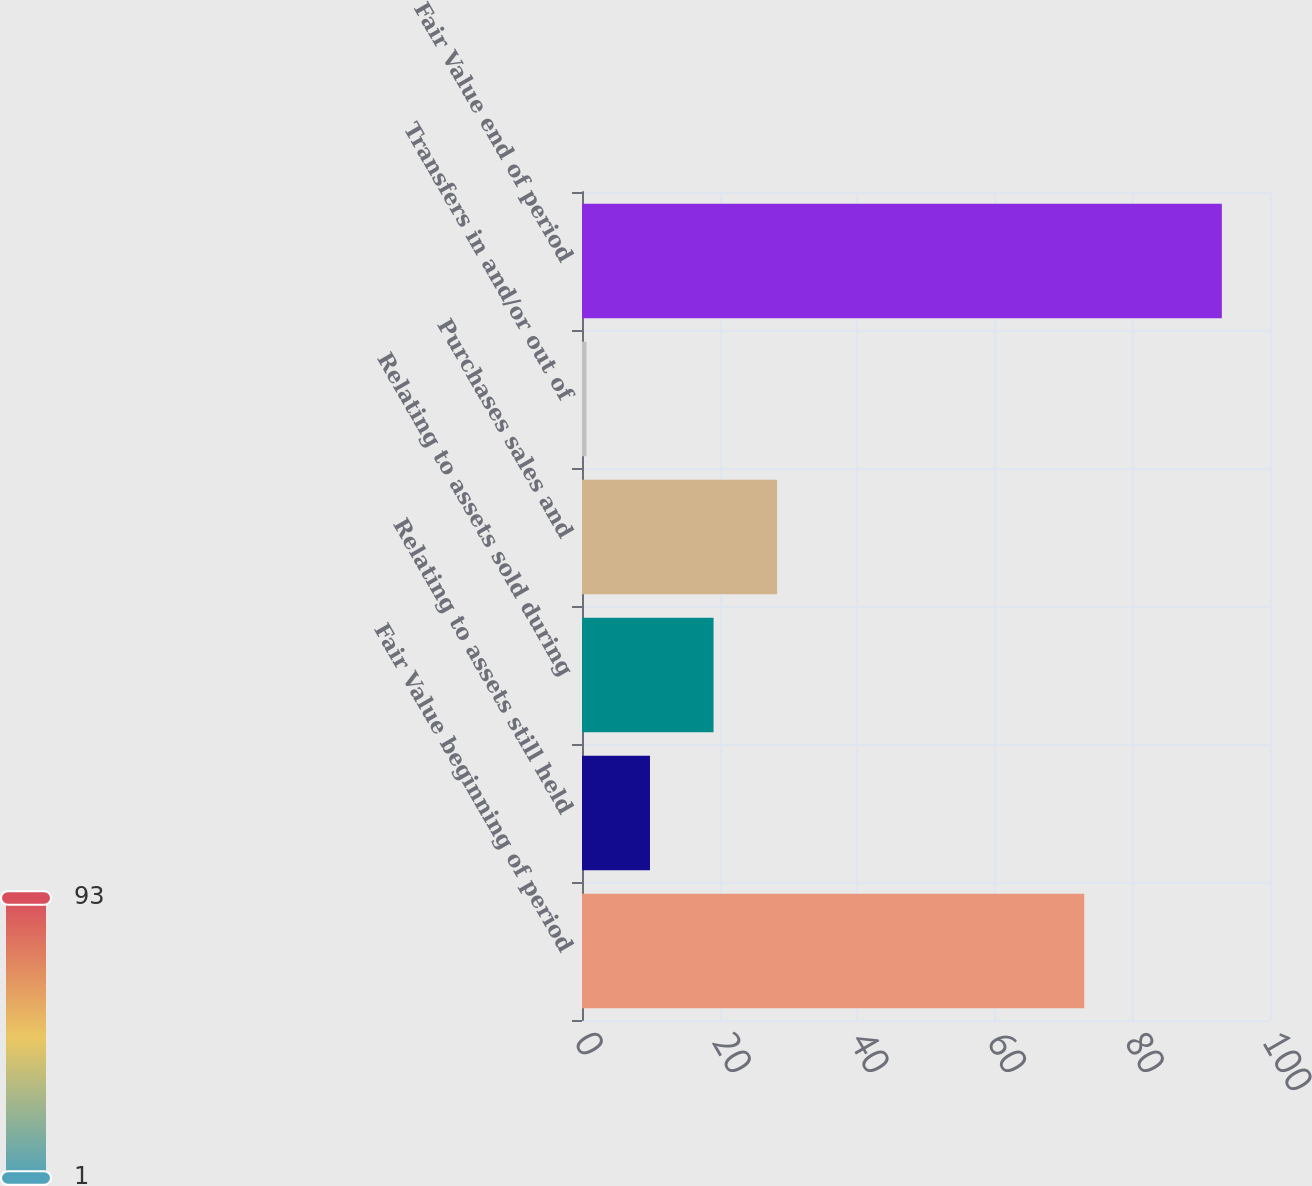<chart> <loc_0><loc_0><loc_500><loc_500><bar_chart><fcel>Fair Value beginning of period<fcel>Relating to assets still held<fcel>Relating to assets sold during<fcel>Purchases sales and<fcel>Transfers in and/or out of<fcel>Fair Value end of period<nl><fcel>73<fcel>9.88<fcel>19.12<fcel>28.36<fcel>0.65<fcel>93<nl></chart> 